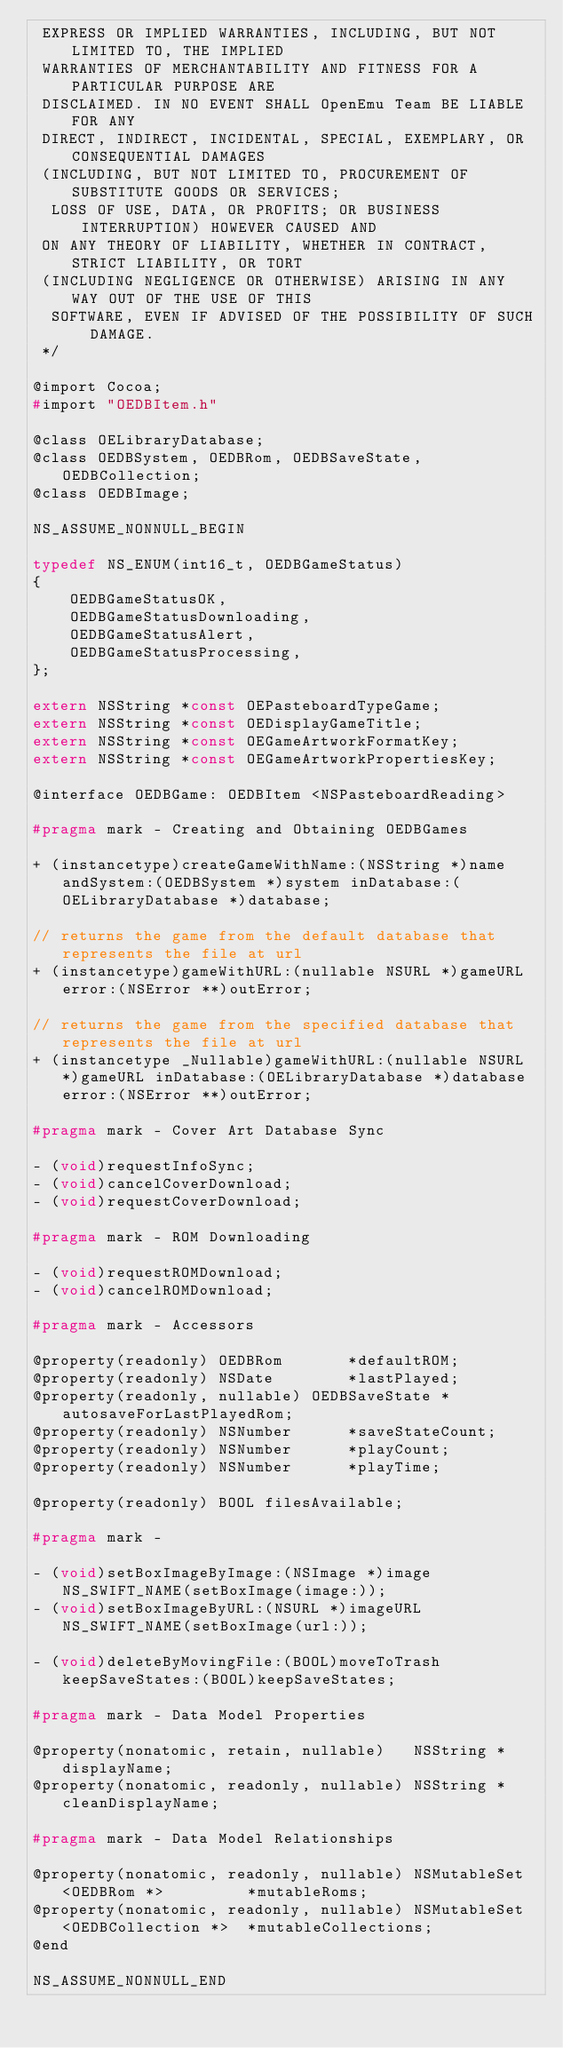<code> <loc_0><loc_0><loc_500><loc_500><_C_> EXPRESS OR IMPLIED WARRANTIES, INCLUDING, BUT NOT LIMITED TO, THE IMPLIED
 WARRANTIES OF MERCHANTABILITY AND FITNESS FOR A PARTICULAR PURPOSE ARE
 DISCLAIMED. IN NO EVENT SHALL OpenEmu Team BE LIABLE FOR ANY
 DIRECT, INDIRECT, INCIDENTAL, SPECIAL, EXEMPLARY, OR CONSEQUENTIAL DAMAGES
 (INCLUDING, BUT NOT LIMITED TO, PROCUREMENT OF SUBSTITUTE GOODS OR SERVICES;
  LOSS OF USE, DATA, OR PROFITS; OR BUSINESS INTERRUPTION) HOWEVER CAUSED AND
 ON ANY THEORY OF LIABILITY, WHETHER IN CONTRACT, STRICT LIABILITY, OR TORT
 (INCLUDING NEGLIGENCE OR OTHERWISE) ARISING IN ANY WAY OUT OF THE USE OF THIS
  SOFTWARE, EVEN IF ADVISED OF THE POSSIBILITY OF SUCH DAMAGE.
 */

@import Cocoa;
#import "OEDBItem.h"

@class OELibraryDatabase;
@class OEDBSystem, OEDBRom, OEDBSaveState, OEDBCollection;
@class OEDBImage;

NS_ASSUME_NONNULL_BEGIN

typedef NS_ENUM(int16_t, OEDBGameStatus)
{
    OEDBGameStatusOK,
    OEDBGameStatusDownloading,
    OEDBGameStatusAlert,
    OEDBGameStatusProcessing,
};

extern NSString *const OEPasteboardTypeGame;
extern NSString *const OEDisplayGameTitle;
extern NSString *const OEGameArtworkFormatKey;
extern NSString *const OEGameArtworkPropertiesKey;

@interface OEDBGame: OEDBItem <NSPasteboardReading>

#pragma mark - Creating and Obtaining OEDBGames

+ (instancetype)createGameWithName:(NSString *)name andSystem:(OEDBSystem *)system inDatabase:(OELibraryDatabase *)database;

// returns the game from the default database that represents the file at url
+ (instancetype)gameWithURL:(nullable NSURL *)gameURL error:(NSError **)outError;

// returns the game from the specified database that represents the file at url
+ (instancetype _Nullable)gameWithURL:(nullable NSURL *)gameURL inDatabase:(OELibraryDatabase *)database error:(NSError **)outError;

#pragma mark - Cover Art Database Sync

- (void)requestInfoSync;
- (void)cancelCoverDownload;
- (void)requestCoverDownload;

#pragma mark - ROM Downloading

- (void)requestROMDownload;
- (void)cancelROMDownload;

#pragma mark - Accessors

@property(readonly) OEDBRom       *defaultROM;
@property(readonly) NSDate        *lastPlayed;
@property(readonly, nullable) OEDBSaveState *autosaveForLastPlayedRom;
@property(readonly) NSNumber      *saveStateCount;
@property(readonly) NSNumber      *playCount;
@property(readonly) NSNumber      *playTime;

@property(readonly) BOOL filesAvailable;

#pragma mark -

- (void)setBoxImageByImage:(NSImage *)image NS_SWIFT_NAME(setBoxImage(image:));
- (void)setBoxImageByURL:(NSURL *)imageURL NS_SWIFT_NAME(setBoxImage(url:));

- (void)deleteByMovingFile:(BOOL)moveToTrash keepSaveStates:(BOOL)keepSaveStates;

#pragma mark - Data Model Properties

@property(nonatomic, retain, nullable)   NSString *displayName;
@property(nonatomic, readonly, nullable) NSString *cleanDisplayName;

#pragma mark - Data Model Relationships

@property(nonatomic, readonly, nullable) NSMutableSet <OEDBRom *>         *mutableRoms;
@property(nonatomic, readonly, nullable) NSMutableSet <OEDBCollection *>  *mutableCollections;
@end

NS_ASSUME_NONNULL_END
</code> 